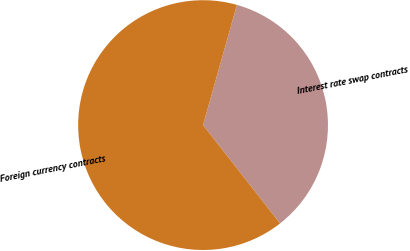<chart> <loc_0><loc_0><loc_500><loc_500><pie_chart><fcel>Interest rate swap contracts<fcel>Foreign currency contracts<nl><fcel>35.06%<fcel>64.94%<nl></chart> 